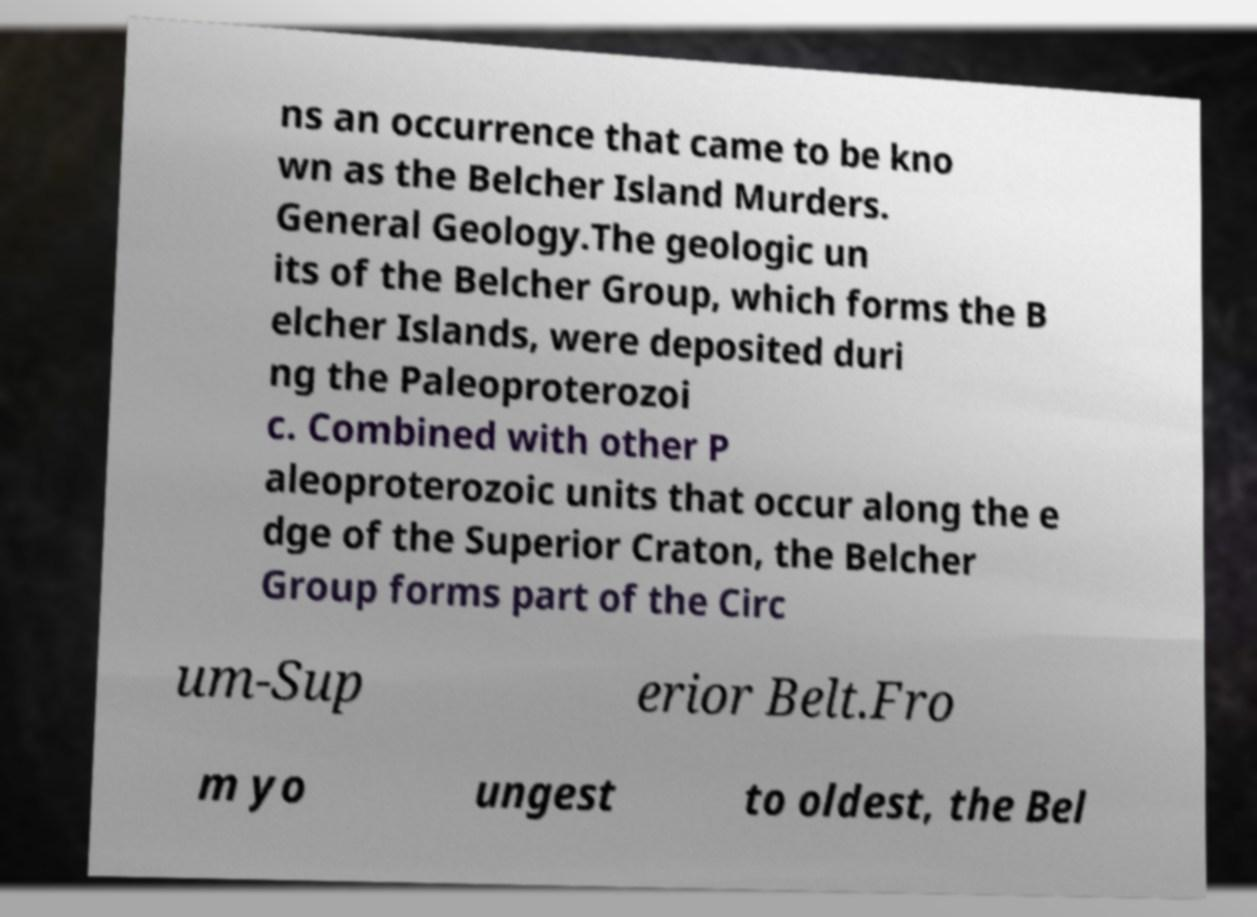There's text embedded in this image that I need extracted. Can you transcribe it verbatim? ns an occurrence that came to be kno wn as the Belcher Island Murders. General Geology.The geologic un its of the Belcher Group, which forms the B elcher Islands, were deposited duri ng the Paleoproterozoi c. Combined with other P aleoproterozoic units that occur along the e dge of the Superior Craton, the Belcher Group forms part of the Circ um-Sup erior Belt.Fro m yo ungest to oldest, the Bel 